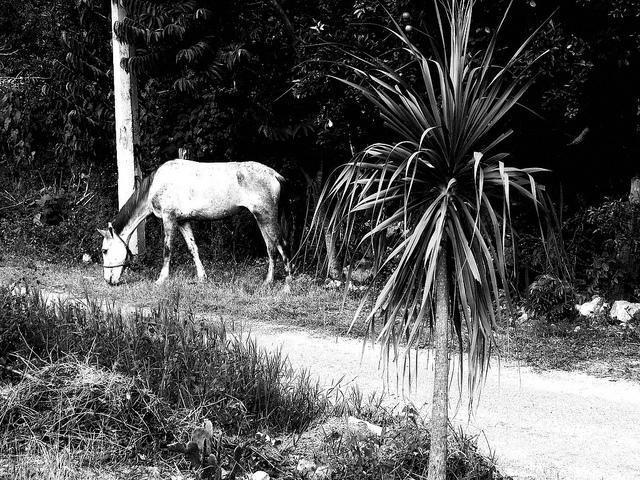How many horses can you see?
Give a very brief answer. 1. How many people are wearing sunglasses?
Give a very brief answer. 0. 